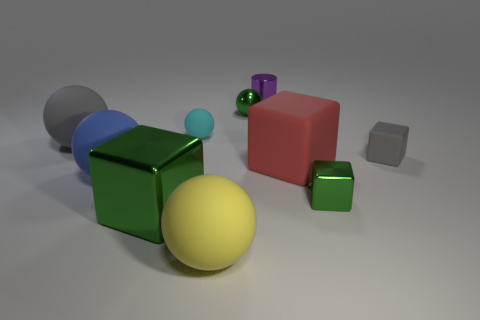Subtract all gray cubes. How many cubes are left? 3 Subtract all cubes. How many objects are left? 6 Subtract 3 blocks. How many blocks are left? 1 Subtract all red blocks. Subtract all yellow cylinders. How many blocks are left? 3 Subtract all green blocks. How many gray spheres are left? 1 Subtract all red matte things. Subtract all big gray things. How many objects are left? 8 Add 2 cyan spheres. How many cyan spheres are left? 3 Add 7 tiny green shiny objects. How many tiny green shiny objects exist? 9 Subtract all yellow balls. How many balls are left? 4 Subtract 1 red cubes. How many objects are left? 9 